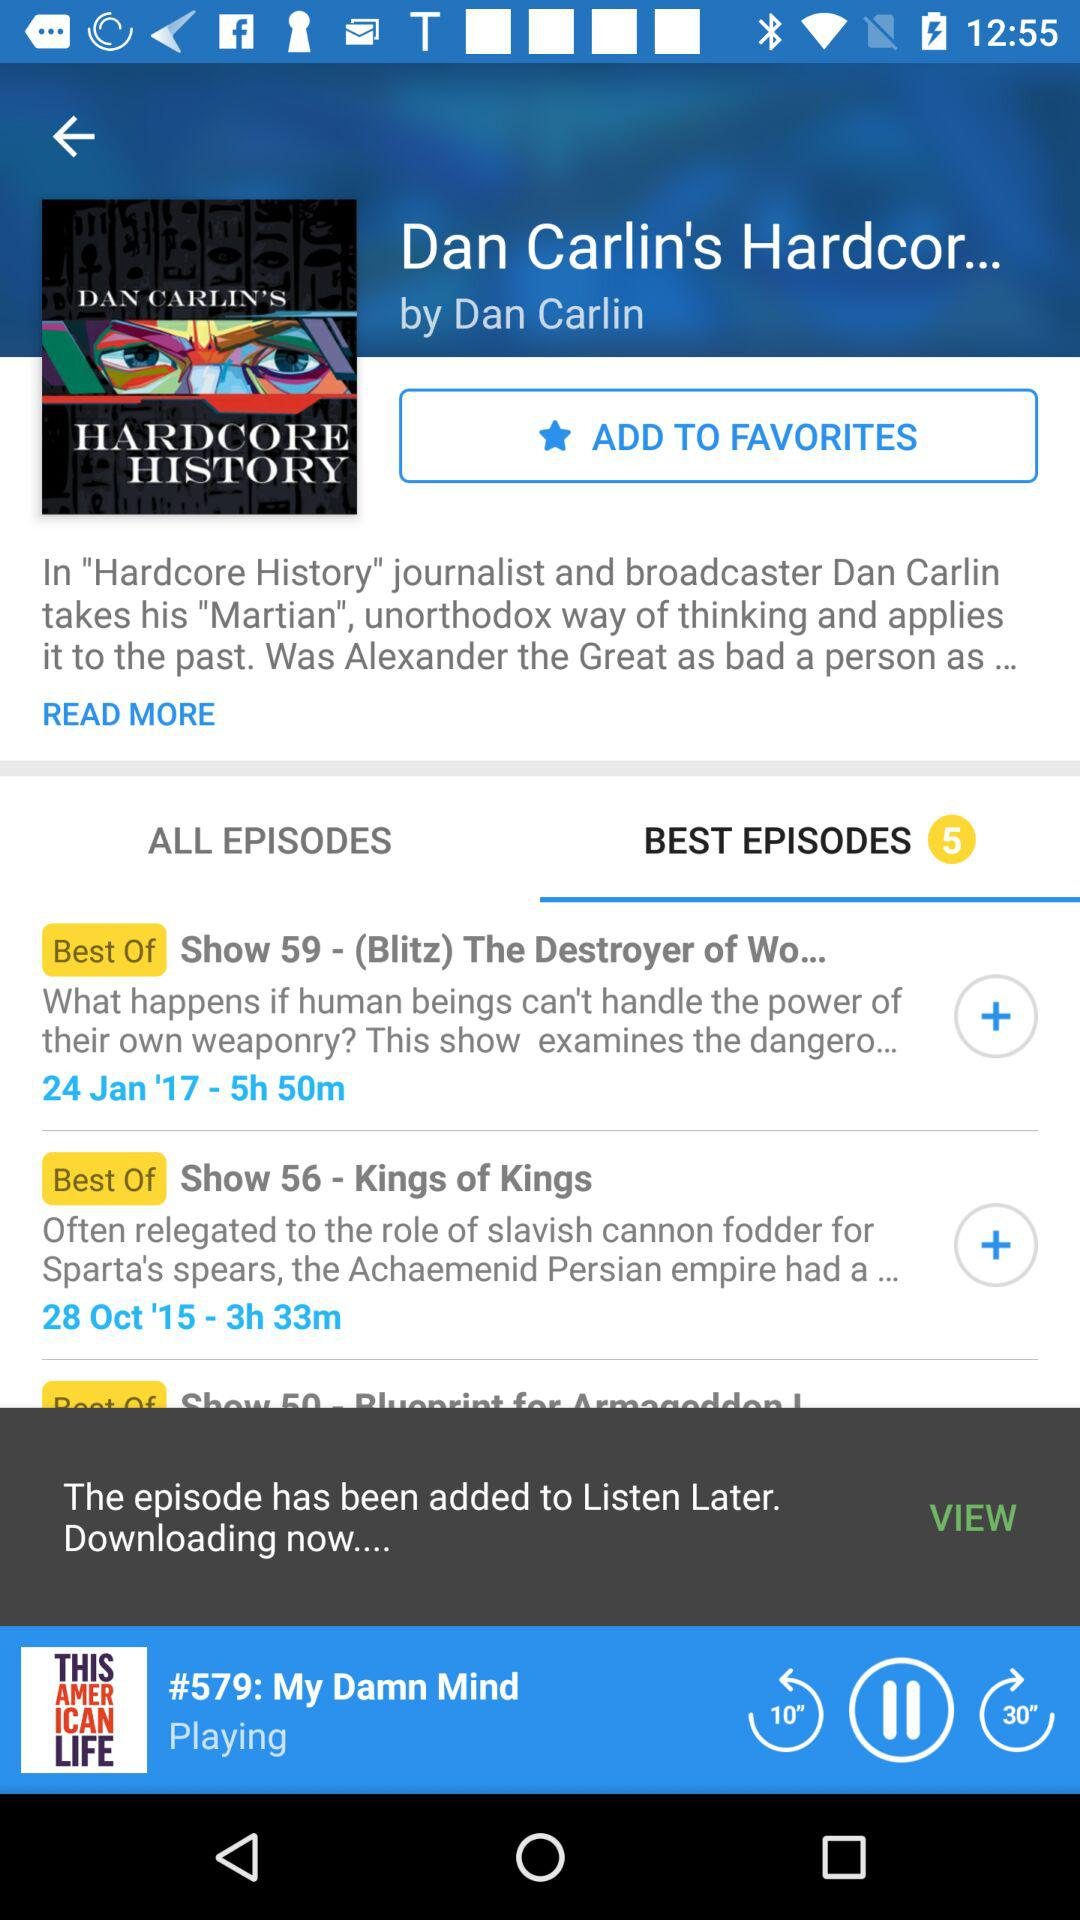How many best episodes are there? There are 5 best episodes. 